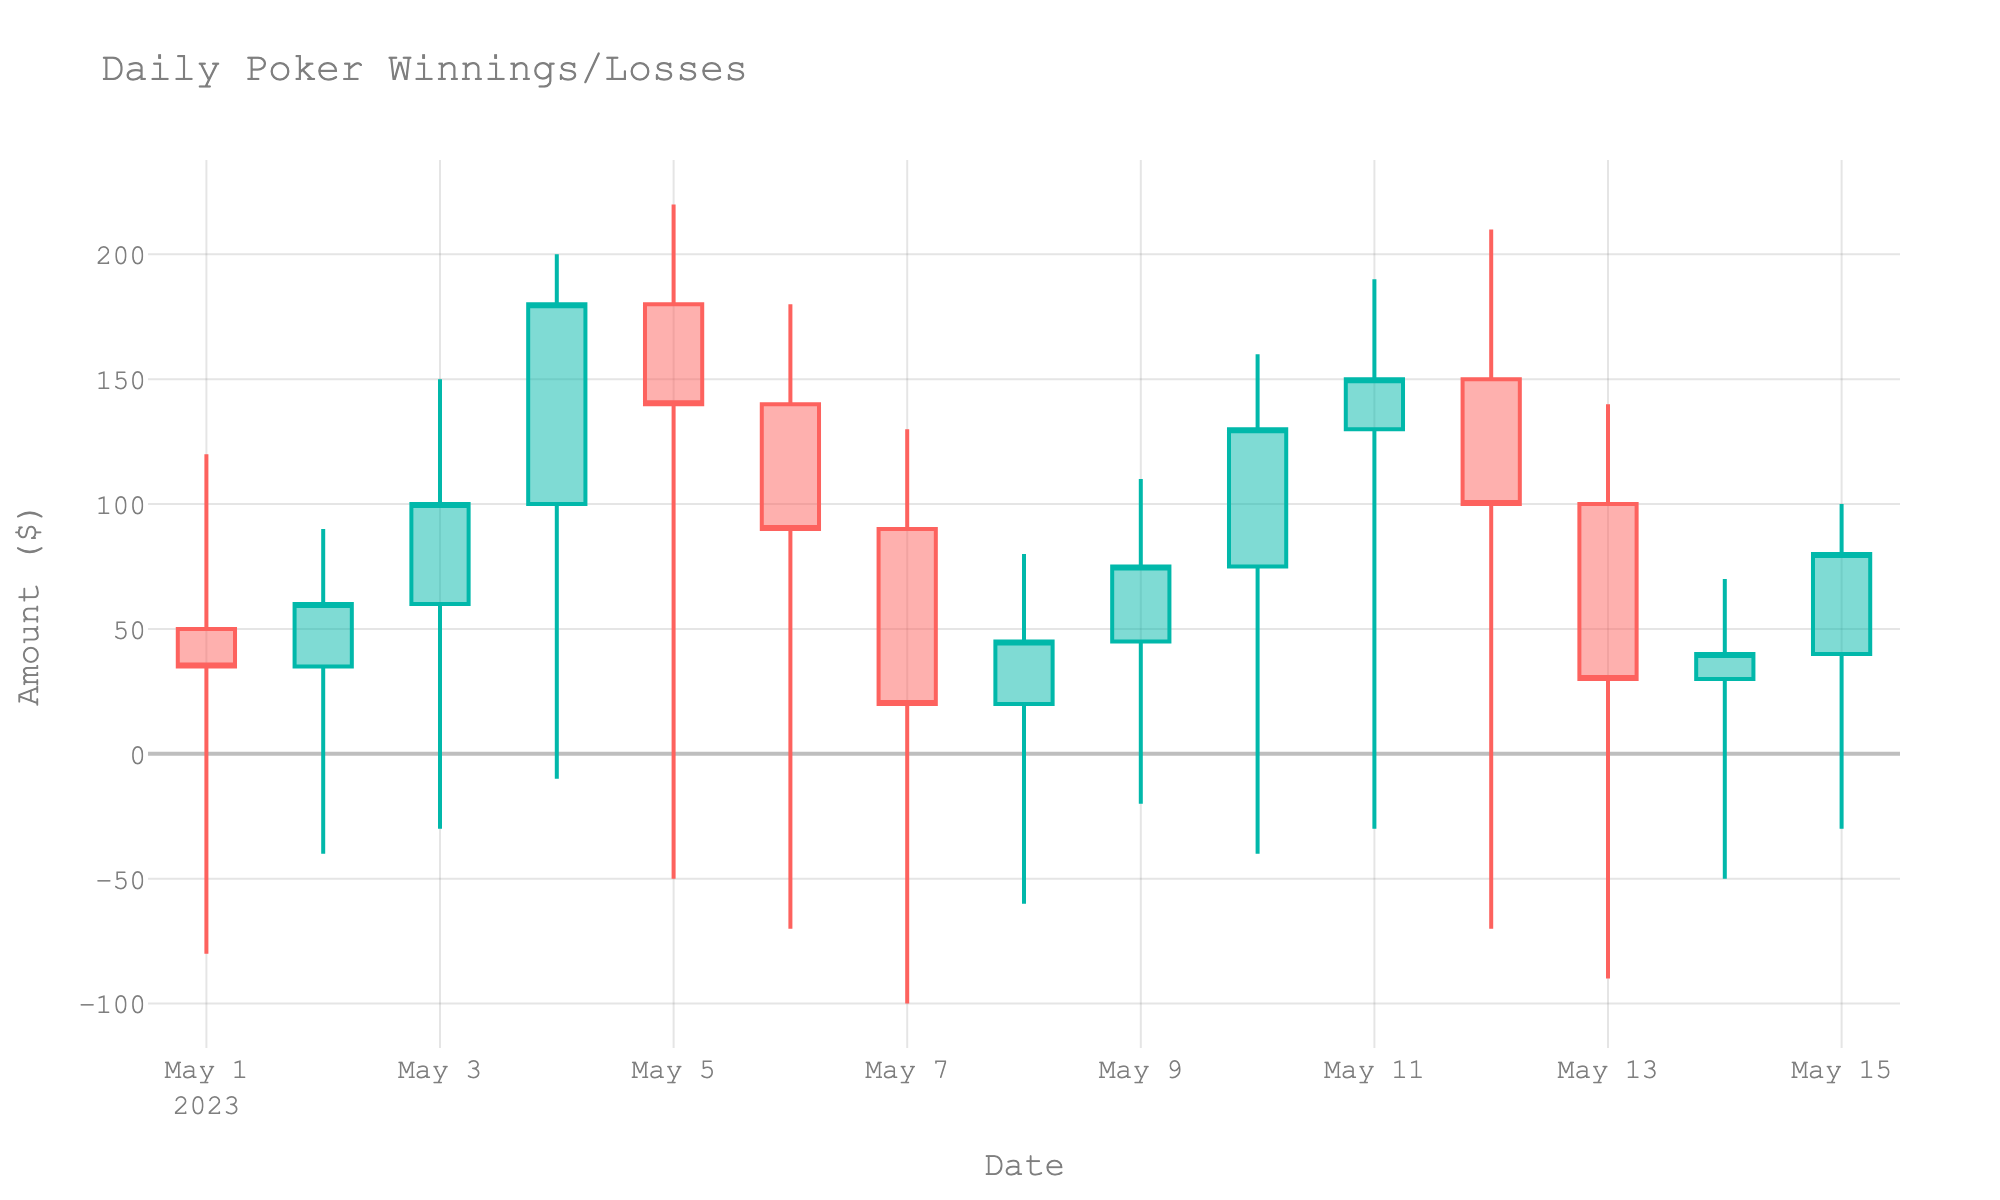what is the title of the figure? The title is clearly displayed at the top of the figure.
Answer: Daily Poker Winnings/Losses how many data points does the chart display? The x-axis shows the dates from May 1 to May 15 in the figure, indicating 15 data points.
Answer: 15 which date had the highest 'High' value and what was it? The highest 'High' value can be seen on May 4 when it reached 200.
Answer: May 4, 200 which date had the lowest 'Low' value and what was it? The lowest 'Low' value can be seen on May 7 when it dropped to -100.
Answer: May 7, -100 how does the color scheme help distinguish between winning and losing sessions? The figure uses different colors for increasing (greenish) and decreasing (reddish) trends. This visual distinction helps in quickly identifying winning (increasing) and losing (decreasing) sessions.
Answer: greenish for winning, reddish for losing on how many days did the session close lower than it opened? Look at each candlestick and check if the closing value is lower than the opening value. This happens on May 5, May 6, May 7, May 12, and May 13.
Answer: 5 days which date had the smallest range between the 'High' and 'Low'? What was the range? The range for each date is calculated as 'High - Low'. The smallest range appears on May 14, where the range is 70 - (-50) = 120.
Answer: May 14, 120 what was the total amount gained or lost from May 1 to May 15? Sum the 'Close' values from May 1 to May 15: 35+60+100+180+140+90+20+45+75+130+150+100+30+40+80 = 1275.
Answer: 1275 how many days did the 'Close' value exceed the 'Open' value by more than 50 dollars? Compare each day's 'Close' and 'Open' values. This occurs on May 3 (100-60), May 4 (180-100), and May 10 (130-75).
Answer: 3 days which date had the highest single-day gain and what was the gain? The highest single-day gain is the largest positive difference between 'Close' and 'Open', occurring on May 4 with a gain of 180 - 100 = 80.
Answer: May 4, 80 